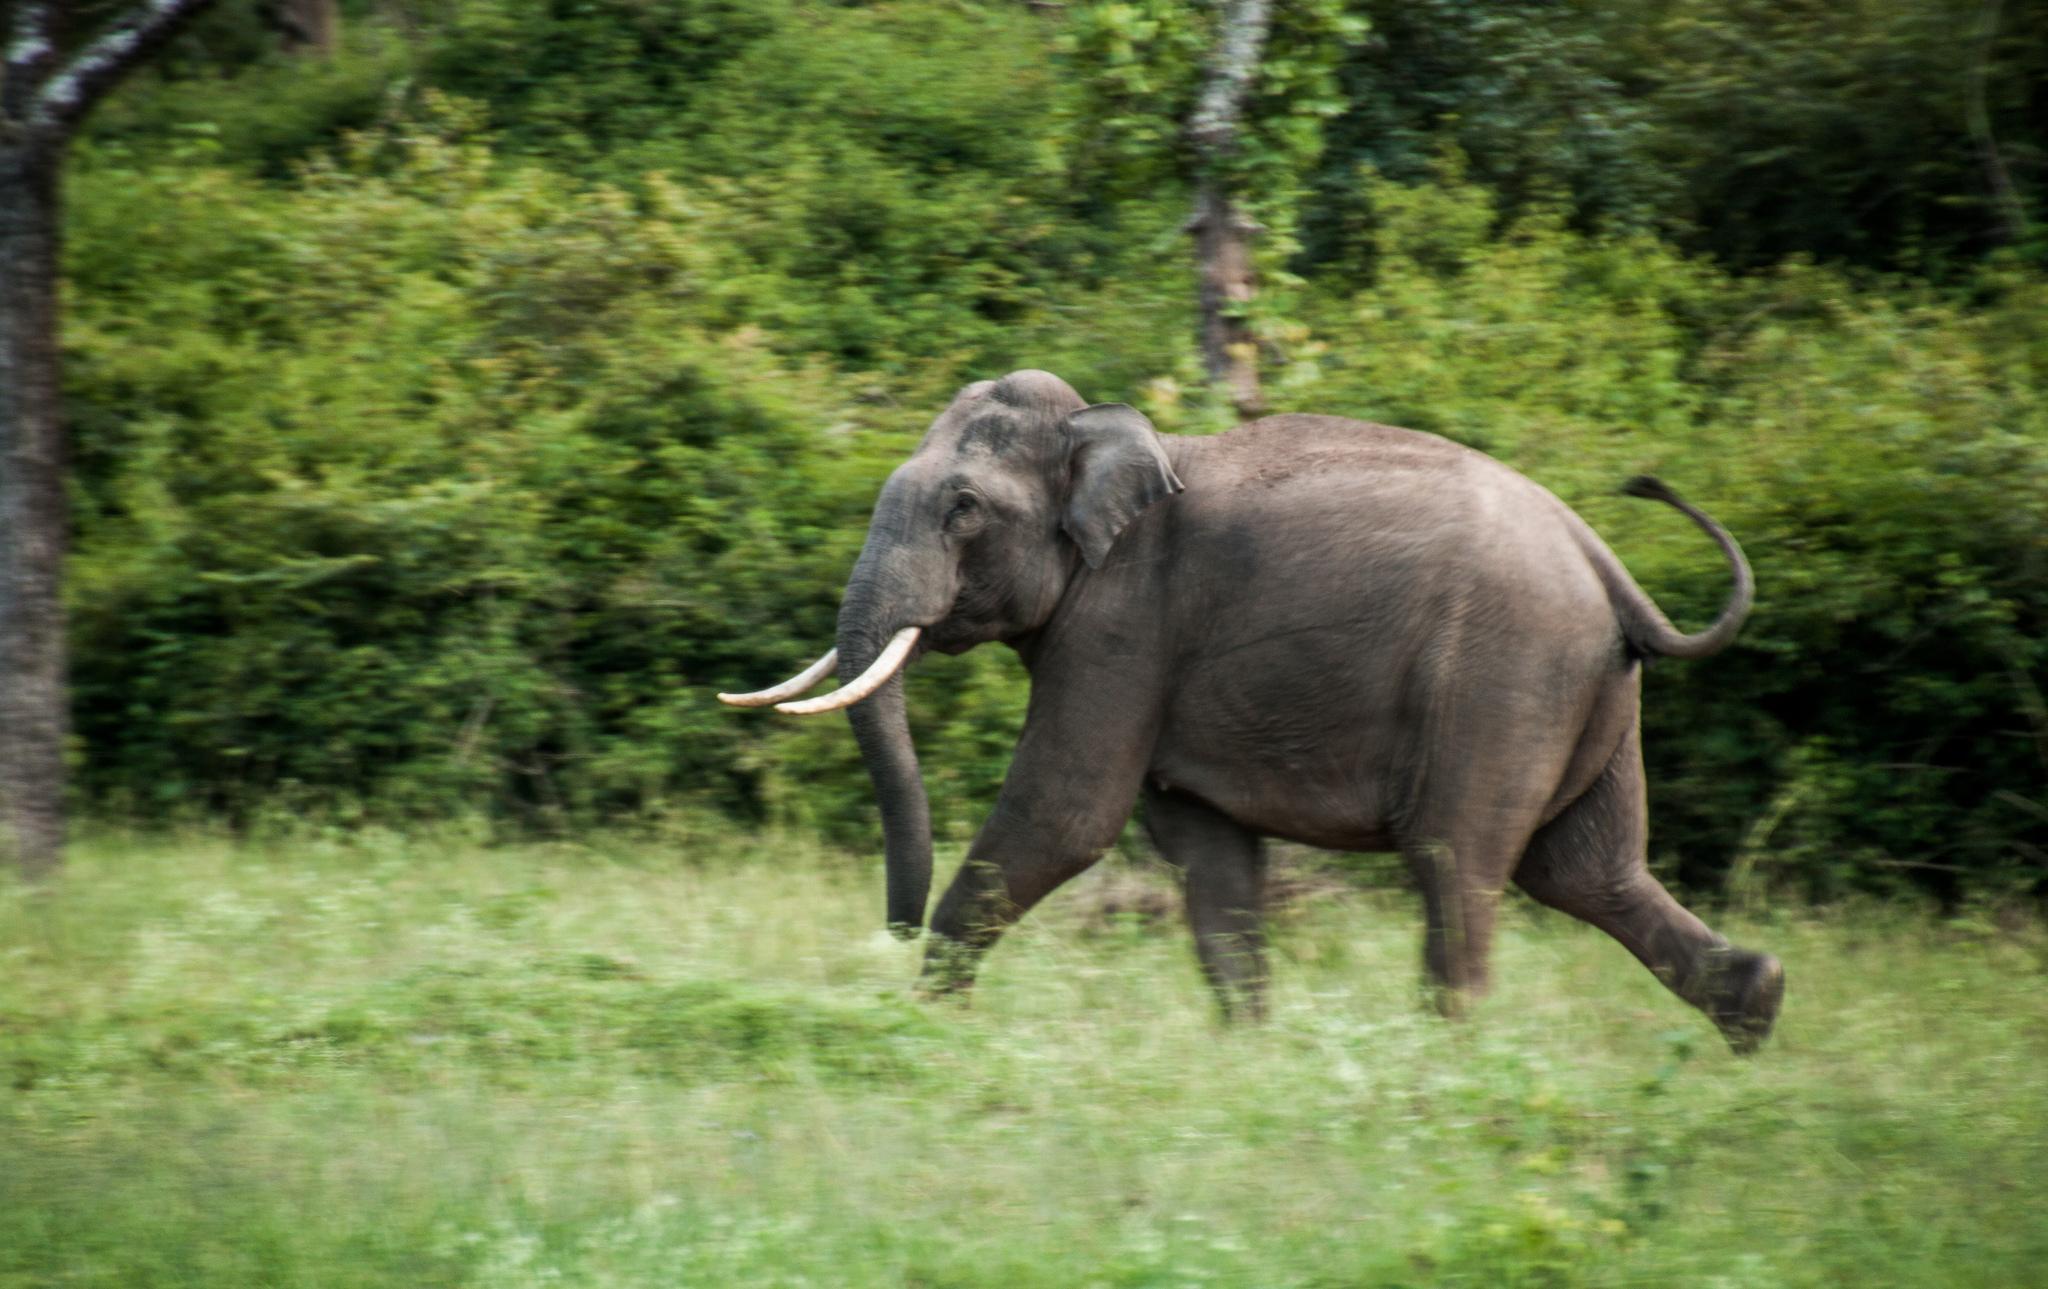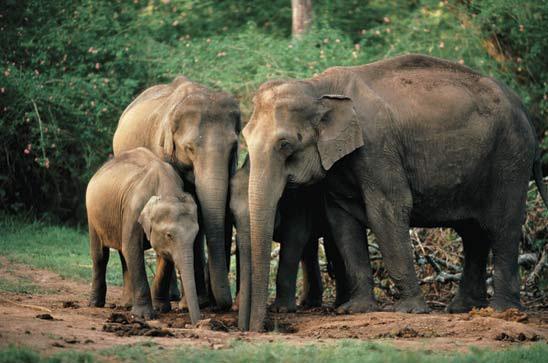The first image is the image on the left, the second image is the image on the right. Considering the images on both sides, is "An image shows a close group of exactly four elephants and includes animals of different ages." valid? Answer yes or no. Yes. The first image is the image on the left, the second image is the image on the right. Assess this claim about the two images: "There is one elephant in green grass in the image on the left.". Correct or not? Answer yes or no. Yes. 